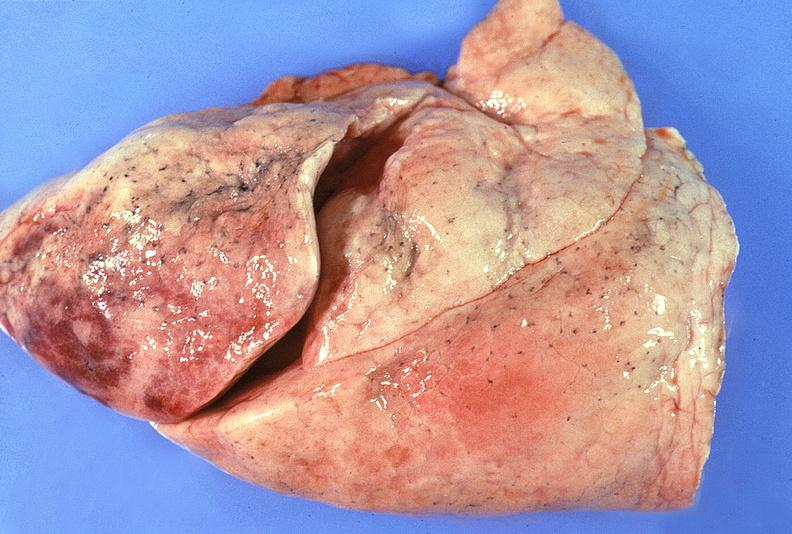what is present?
Answer the question using a single word or phrase. Respiratory 